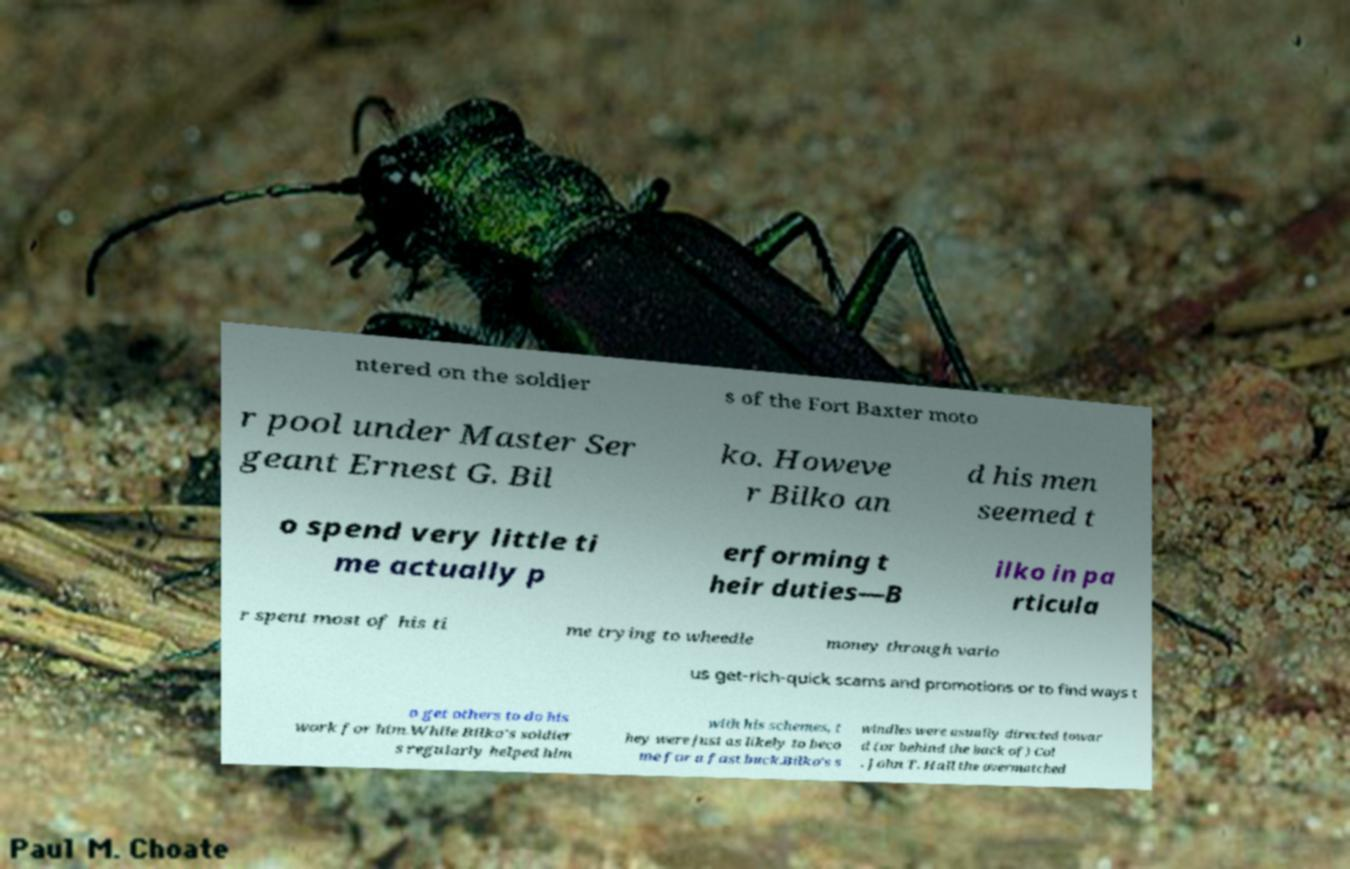Could you assist in decoding the text presented in this image and type it out clearly? ntered on the soldier s of the Fort Baxter moto r pool under Master Ser geant Ernest G. Bil ko. Howeve r Bilko an d his men seemed t o spend very little ti me actually p erforming t heir duties—B ilko in pa rticula r spent most of his ti me trying to wheedle money through vario us get-rich-quick scams and promotions or to find ways t o get others to do his work for him.While Bilko's soldier s regularly helped him with his schemes, t hey were just as likely to beco me for a fast buck.Bilko's s windles were usually directed towar d (or behind the back of) Col . John T. Hall the overmatched 